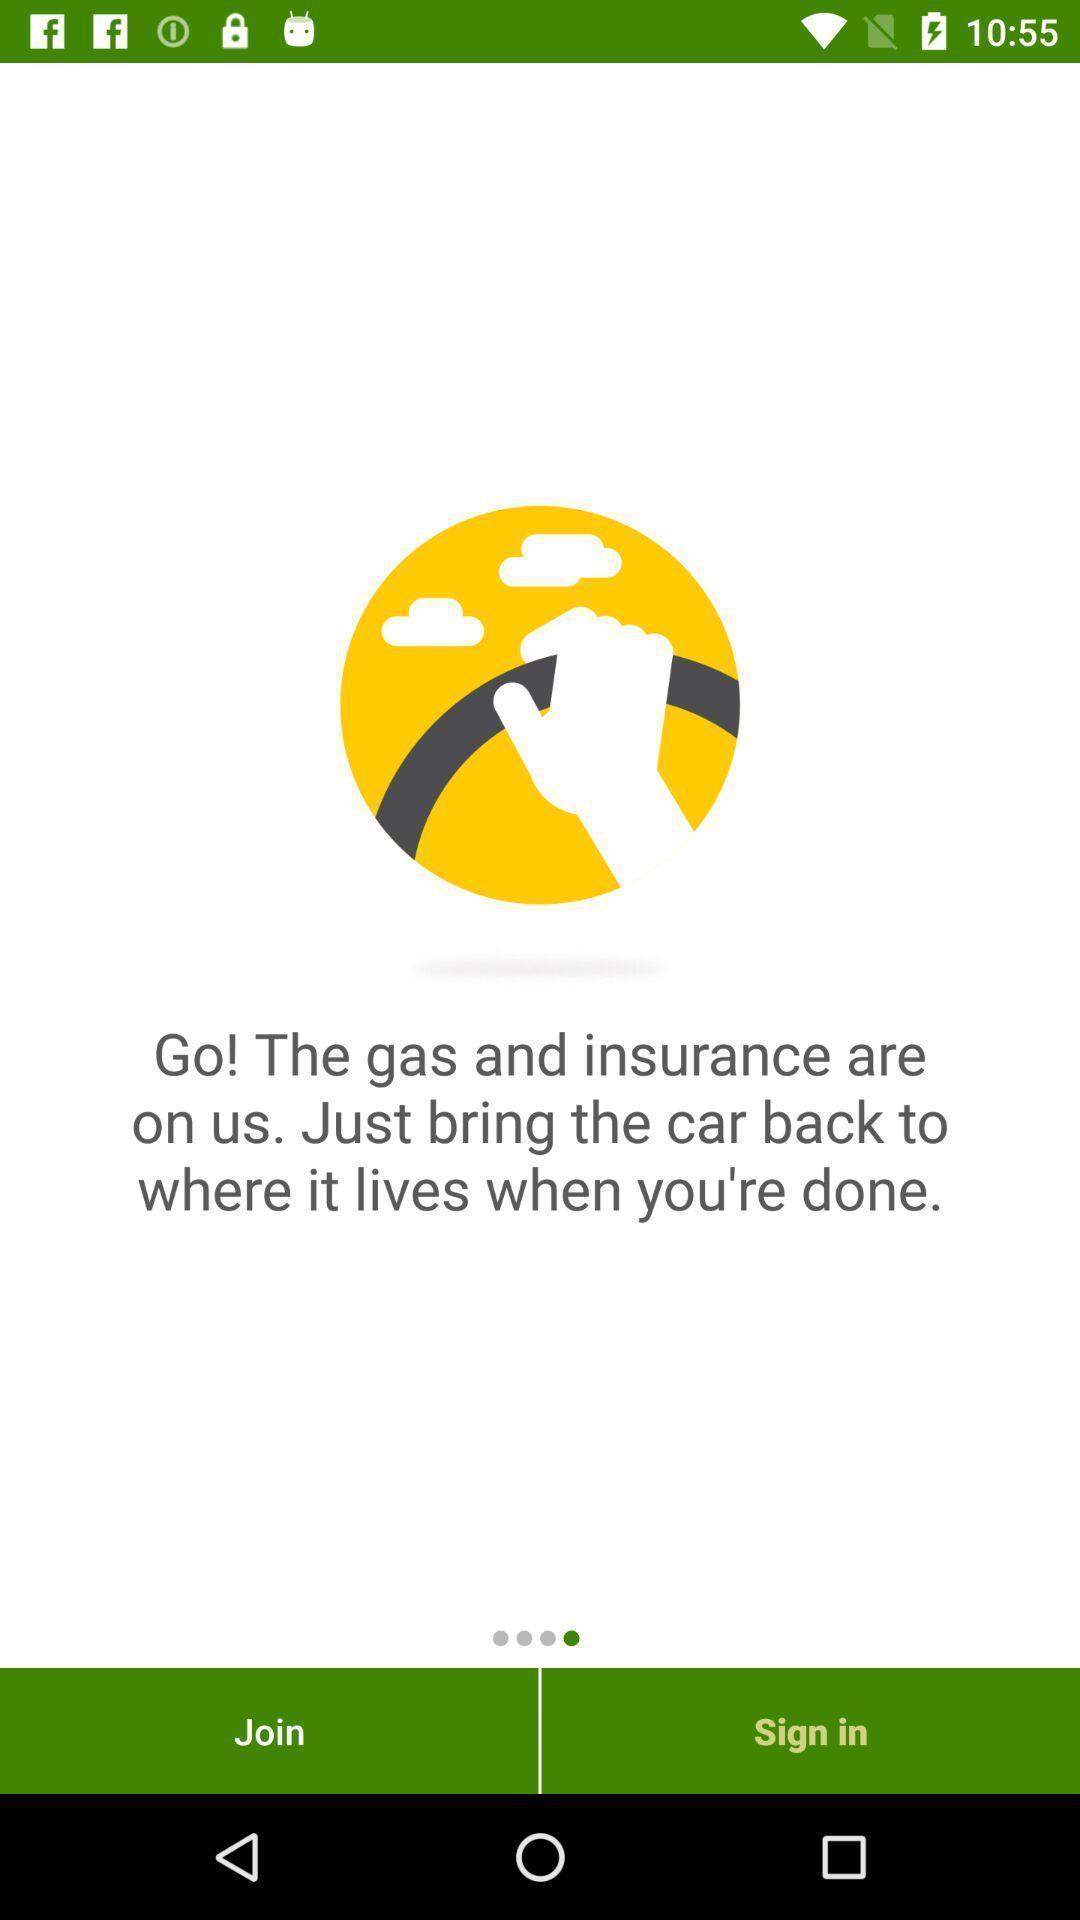Summarize the main components in this picture. Welcome page displaying to join or login to application. 